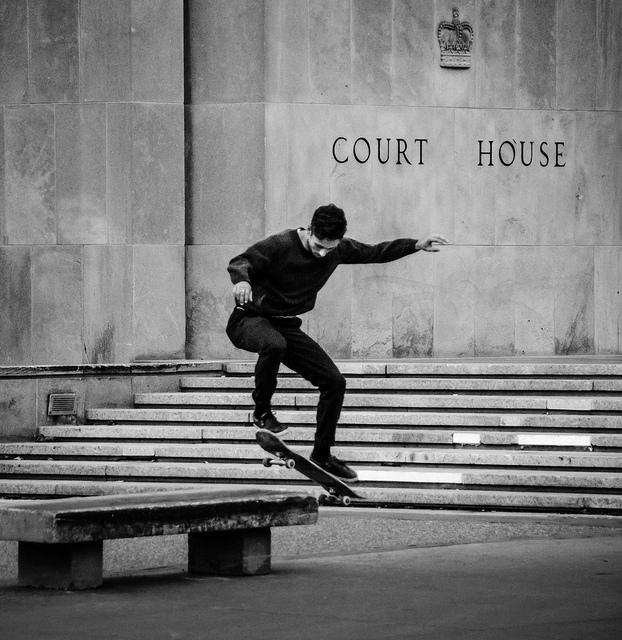What type of building is in the background?
Short answer required. Courthouse. Is the man on the stairs?
Write a very short answer. No. What's the name of that trick?
Concise answer only. Ollie. 